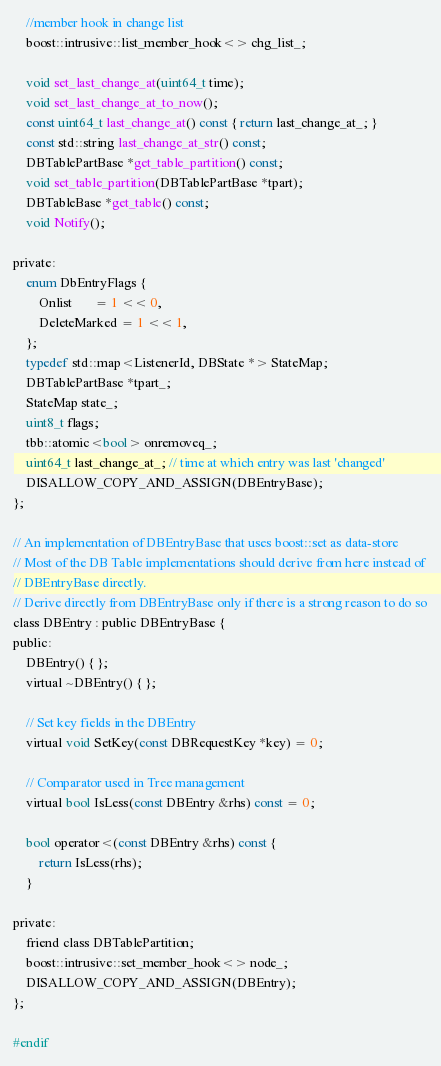<code> <loc_0><loc_0><loc_500><loc_500><_C_>    //member hook in change list
    boost::intrusive::list_member_hook<> chg_list_;

    void set_last_change_at(uint64_t time);
    void set_last_change_at_to_now();
    const uint64_t last_change_at() const { return last_change_at_; }
    const std::string last_change_at_str() const;
    DBTablePartBase *get_table_partition() const;
    void set_table_partition(DBTablePartBase *tpart);
    DBTableBase *get_table() const;
    void Notify();

private:
    enum DbEntryFlags {
        Onlist       = 1 << 0,
        DeleteMarked = 1 << 1,
    };
    typedef std::map<ListenerId, DBState *> StateMap;
    DBTablePartBase *tpart_;
    StateMap state_;
    uint8_t flags;
    tbb::atomic<bool> onremoveq_;
    uint64_t last_change_at_; // time at which entry was last 'changed'
    DISALLOW_COPY_AND_ASSIGN(DBEntryBase);
};

// An implementation of DBEntryBase that uses boost::set as data-store
// Most of the DB Table implementations should derive from here instead of
// DBEntryBase directly.
// Derive directly from DBEntryBase only if there is a strong reason to do so
class DBEntry : public DBEntryBase {
public:
    DBEntry() { };
    virtual ~DBEntry() { };

    // Set key fields in the DBEntry
    virtual void SetKey(const DBRequestKey *key) = 0;

    // Comparator used in Tree management
    virtual bool IsLess(const DBEntry &rhs) const = 0;

    bool operator<(const DBEntry &rhs) const {
        return IsLess(rhs);
    }

private:
    friend class DBTablePartition;
    boost::intrusive::set_member_hook<> node_;
    DISALLOW_COPY_AND_ASSIGN(DBEntry);
};

#endif
</code> 